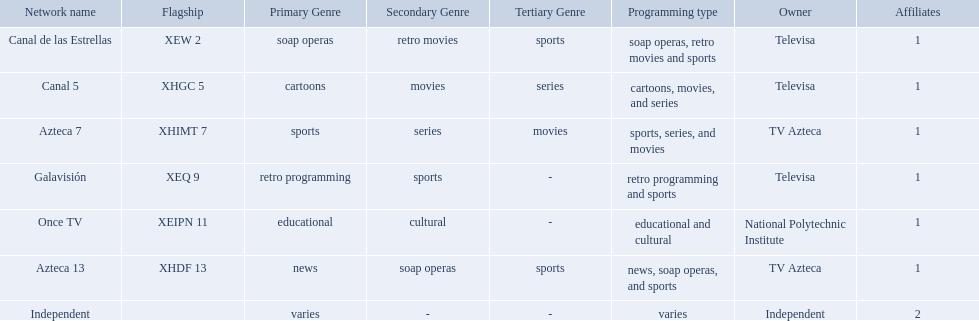What station shows cartoons? Canal 5. What station shows soap operas? Canal de las Estrellas. What station shows sports? Azteca 7. What television stations are in morelos? Canal de las Estrellas, Canal 5, Azteca 7, Galavisión, Once TV, Azteca 13, Independent. Of those which network is owned by national polytechnic institute? Once TV. 